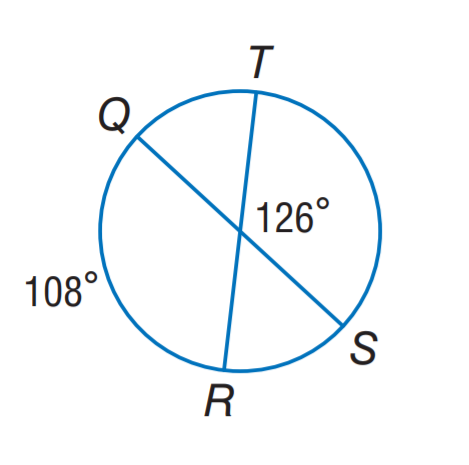Question: Find m \widehat T S.
Choices:
A. 108
B. 126
C. 132
D. 144
Answer with the letter. Answer: D 